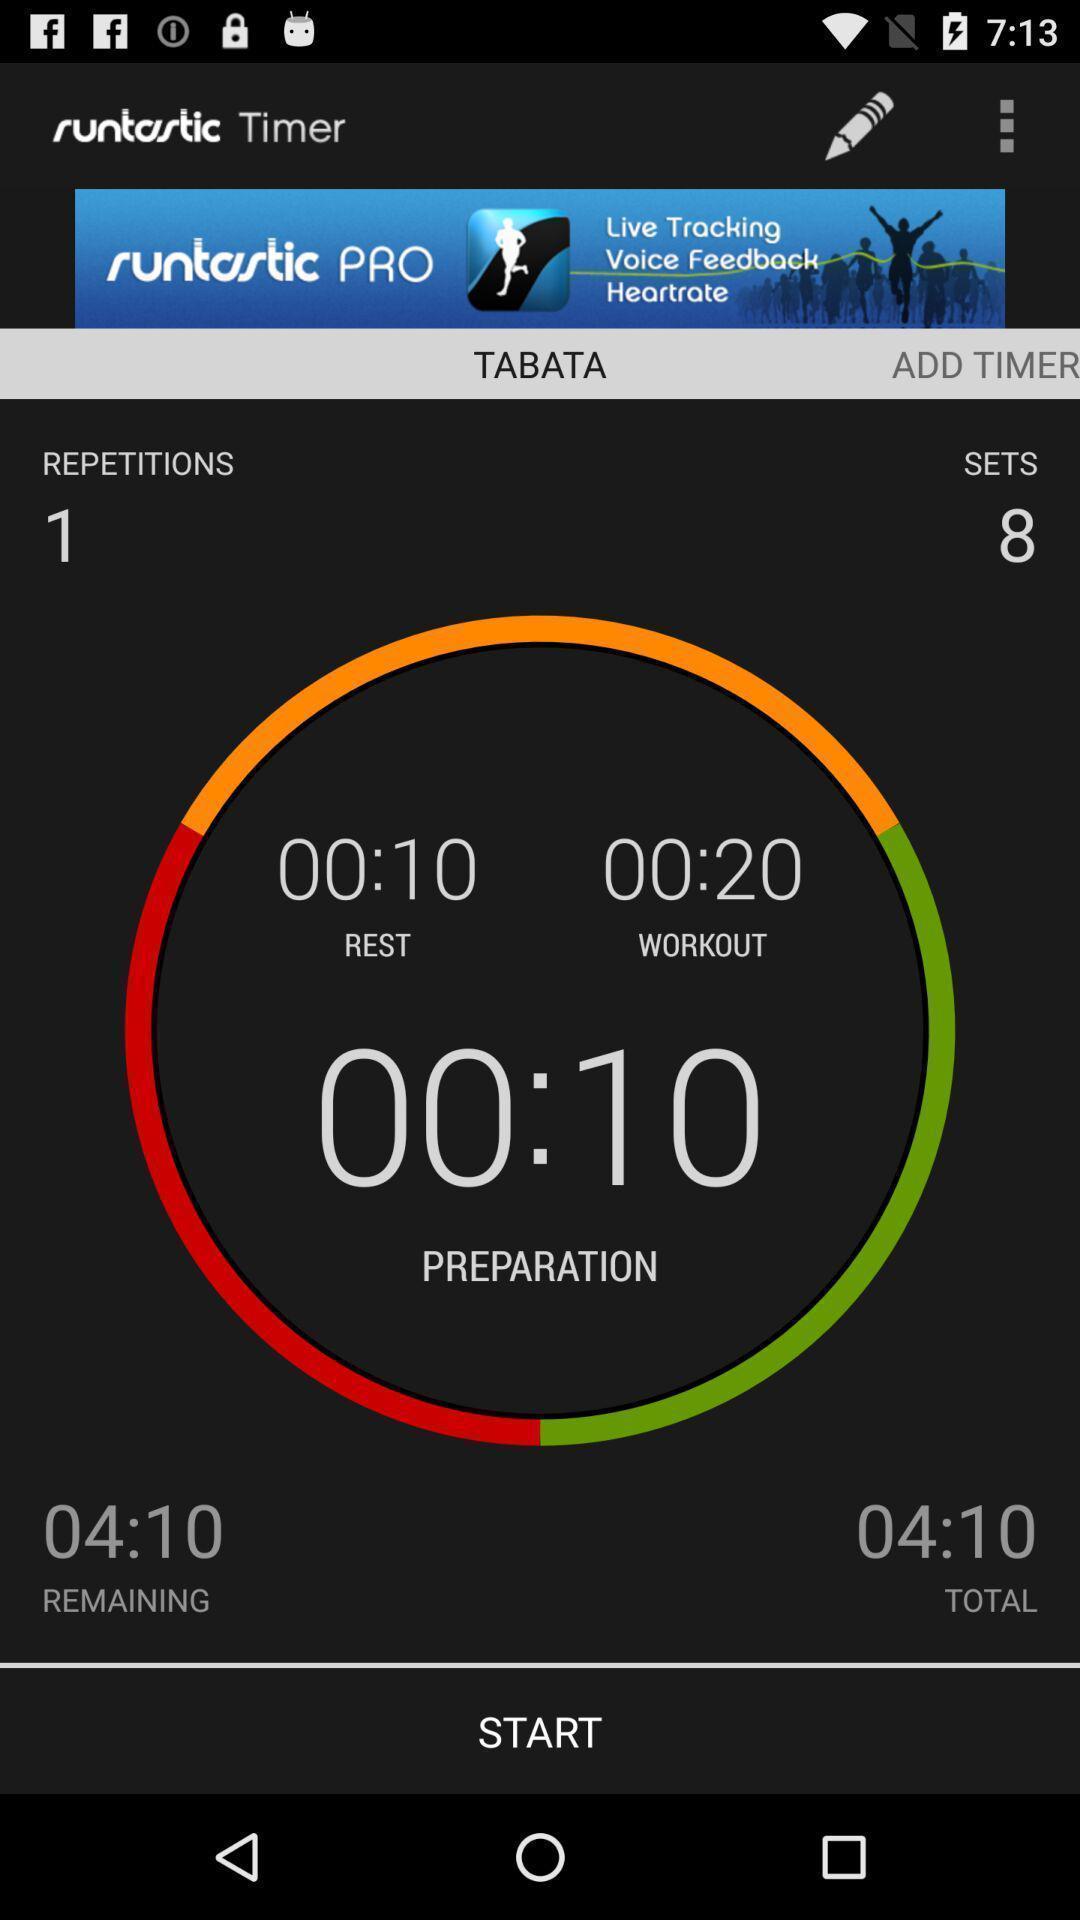Summarize the information in this screenshot. Stop watch setter in the application. 